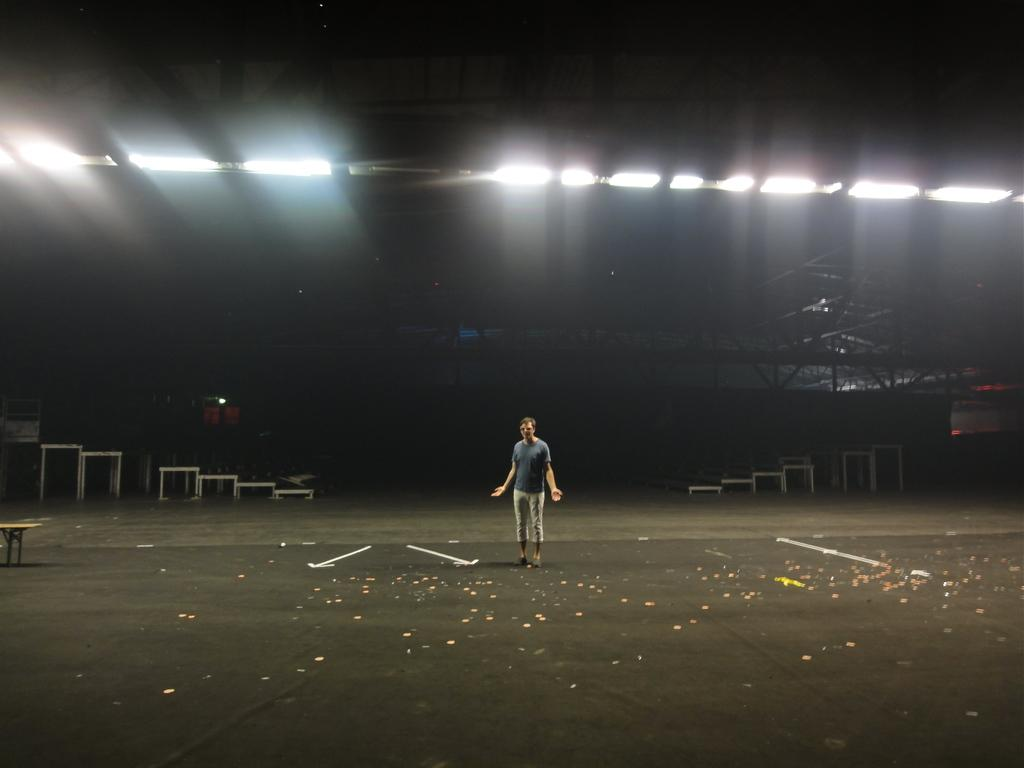What is the main subject of the image? There is a person standing in the image. What is the person standing on? The person is standing on a black surface. What can be seen in the background of the image? The background of the image is dark, and there are tables and ceiling lights visible. What type of wool is being used to make the banana in the image? There is no banana or wool present in the image. 